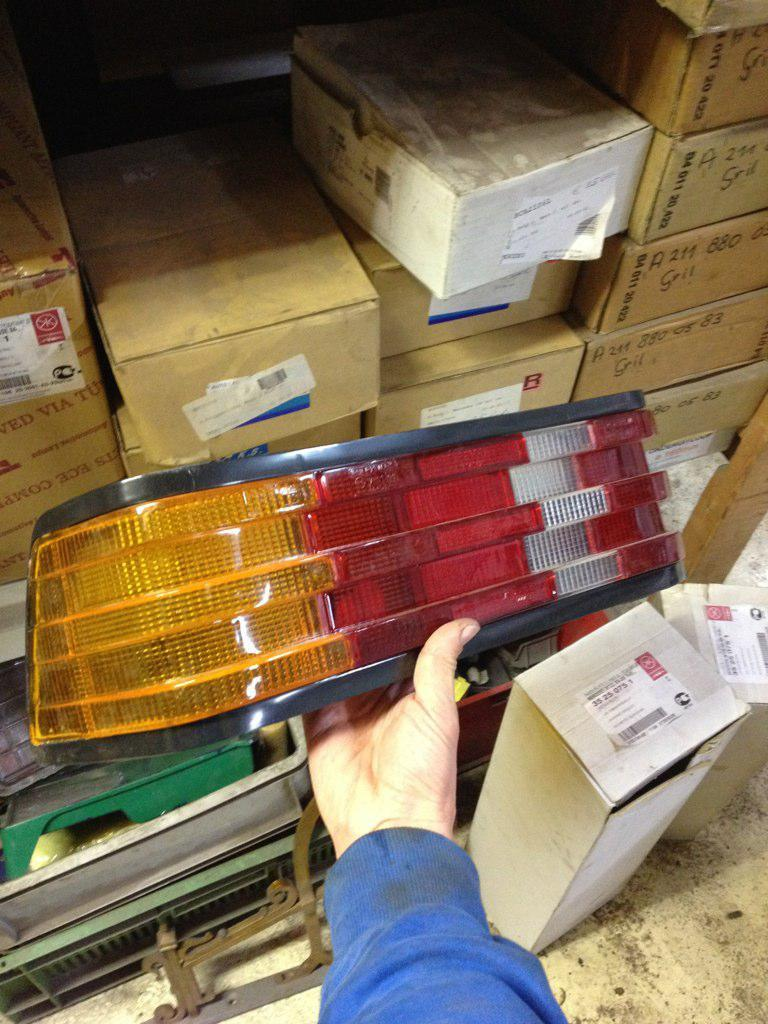What type of containers are visible in the image? There are cardboard cartons in the image. How are the cardboard cartons arranged in the image? The cardboard cartons are arranged on shelves and on the floor. Can you describe the person in the image? The person is holding electric lights in their hands. Can you see a rabbit biting the electric lights in the image? No, there is no rabbit or biting action involving electric lights in the image. 